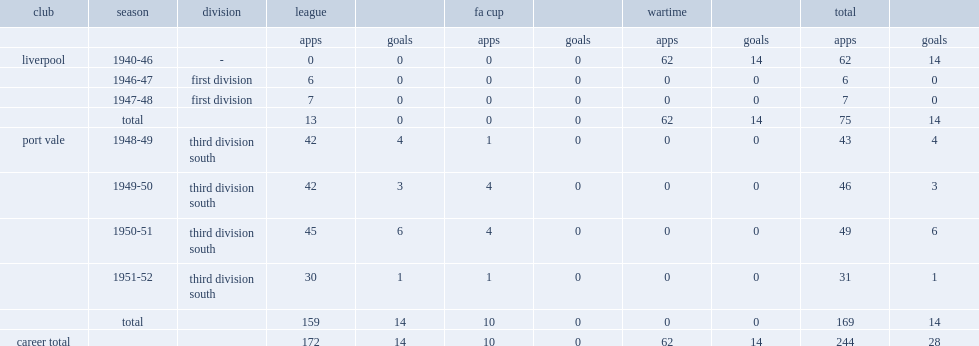What was the number of apps made by stan palk in all competitions ? 169.0. 